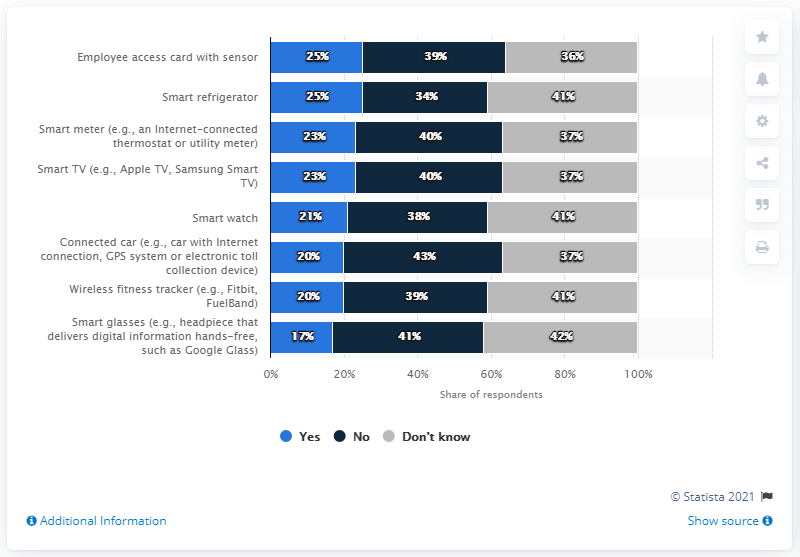Mention a couple of crucial points in this snapshot. The connected car, such as one with an Internet connection, GPS system, or electronic toll collection device, has the highest Np value among the given options. The connected car with the least difference is one that has an internet connection, a GPS system, and an electronic toll collection device. 